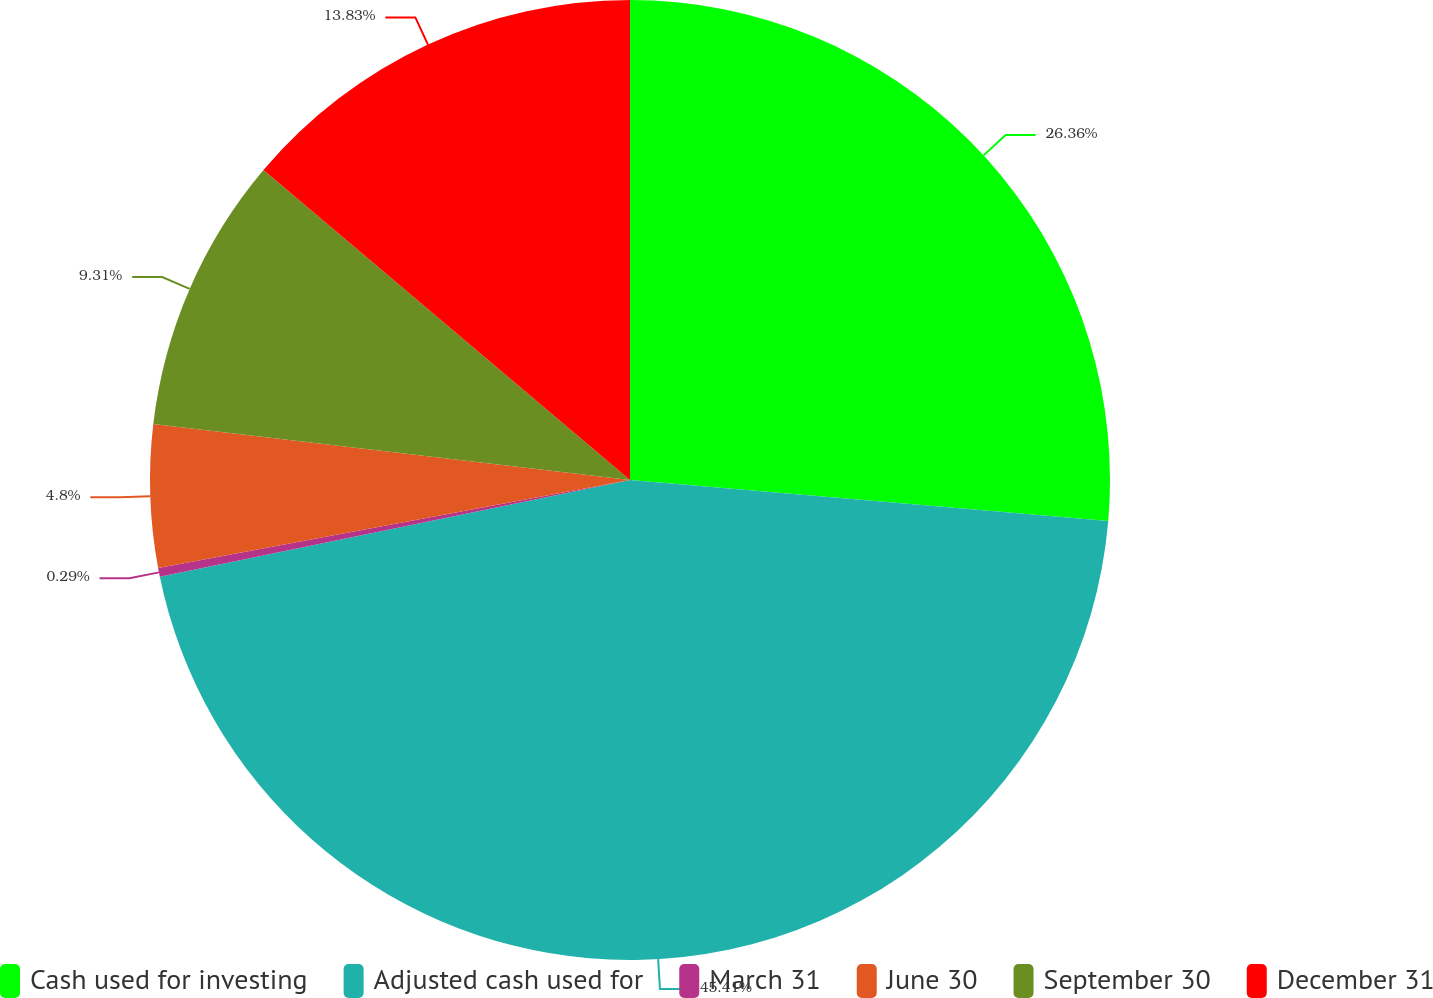Convert chart. <chart><loc_0><loc_0><loc_500><loc_500><pie_chart><fcel>Cash used for investing<fcel>Adjusted cash used for<fcel>March 31<fcel>June 30<fcel>September 30<fcel>December 31<nl><fcel>26.36%<fcel>45.42%<fcel>0.29%<fcel>4.8%<fcel>9.31%<fcel>13.83%<nl></chart> 